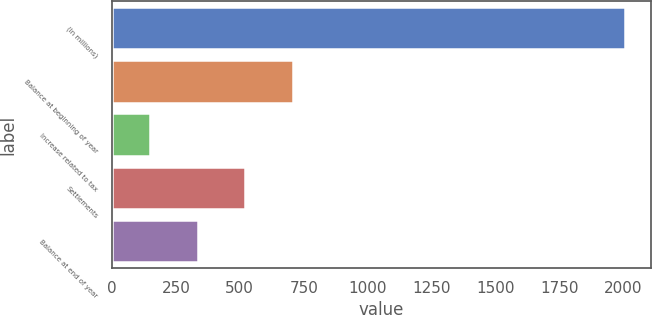Convert chart to OTSL. <chart><loc_0><loc_0><loc_500><loc_500><bar_chart><fcel>(In millions)<fcel>Balance at beginning of year<fcel>Increase related to tax<fcel>Settlements<fcel>Balance at end of year<nl><fcel>2007<fcel>707.1<fcel>150<fcel>521.4<fcel>335.7<nl></chart> 